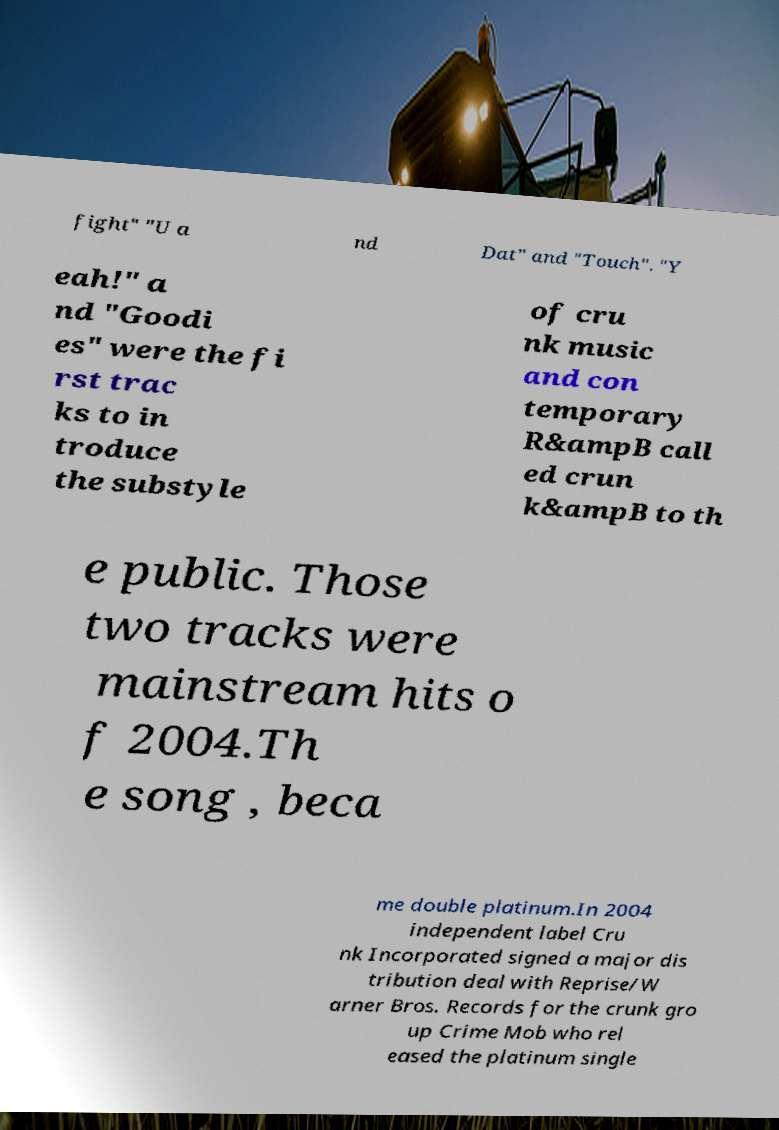Could you extract and type out the text from this image? fight" "U a nd Dat" and "Touch". "Y eah!" a nd "Goodi es" were the fi rst trac ks to in troduce the substyle of cru nk music and con temporary R&ampB call ed crun k&ampB to th e public. Those two tracks were mainstream hits o f 2004.Th e song , beca me double platinum.In 2004 independent label Cru nk Incorporated signed a major dis tribution deal with Reprise/W arner Bros. Records for the crunk gro up Crime Mob who rel eased the platinum single 